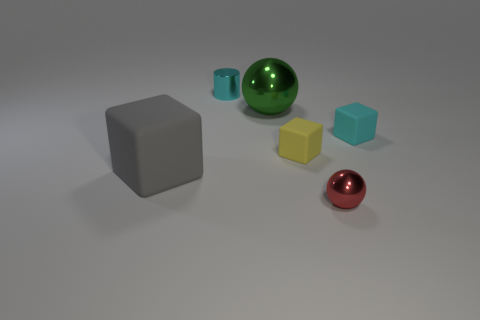Subtract all tiny blocks. How many blocks are left? 1 Add 3 blue cylinders. How many objects exist? 9 Subtract all balls. How many objects are left? 4 Add 4 large matte blocks. How many large matte blocks are left? 5 Add 2 green rubber blocks. How many green rubber blocks exist? 2 Subtract 0 yellow spheres. How many objects are left? 6 Subtract all green cylinders. Subtract all green blocks. How many cylinders are left? 1 Subtract all tiny red objects. Subtract all tiny shiny cylinders. How many objects are left? 4 